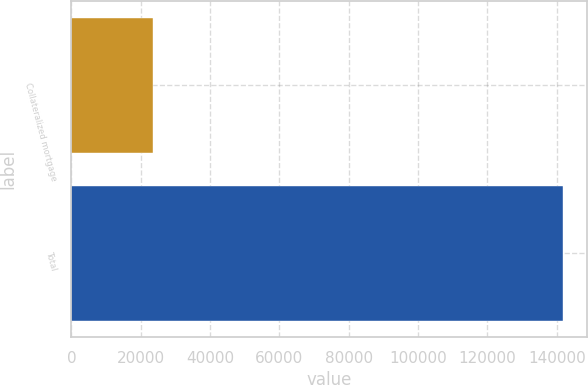Convert chart. <chart><loc_0><loc_0><loc_500><loc_500><bar_chart><fcel>Collateralized mortgage<fcel>Total<nl><fcel>23518<fcel>141745<nl></chart> 